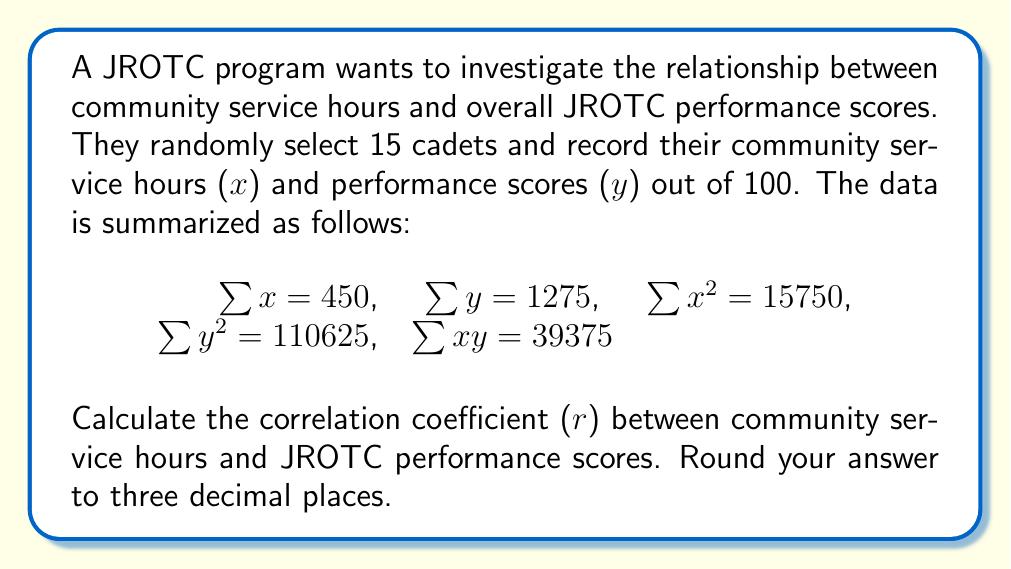Show me your answer to this math problem. To calculate the correlation coefficient (r), we'll use the formula:

$$r = \frac{n\sum xy - \sum x \sum y}{\sqrt{[n\sum x^2 - (\sum x)^2][n\sum y^2 - (\sum y)^2]}}$$

Where n is the number of cadets (15 in this case).

Step 1: Calculate $n\sum xy$
$15 \times 39375 = 590625$

Step 2: Calculate $\sum x \sum y$
$450 \times 1275 = 573750$

Step 3: Calculate the numerator
$590625 - 573750 = 16875$

Step 4: Calculate $n\sum x^2$
$15 \times 15750 = 236250$

Step 5: Calculate $(\sum x)^2$
$450^2 = 202500$

Step 6: Calculate $n\sum y^2$
$15 \times 110625 = 1659375$

Step 7: Calculate $(\sum y)^2$
$1275^2 = 1625625$

Step 8: Calculate the denominator
$\sqrt{[236250 - 202500][1659375 - 1625625]}$
$= \sqrt{33750 \times 33750}$
$= \sqrt{1139062500}$
$= 33750$

Step 9: Calculate r
$r = \frac{16875}{33750} = 0.5$

Therefore, the correlation coefficient is 0.500 when rounded to three decimal places.
Answer: 0.500 